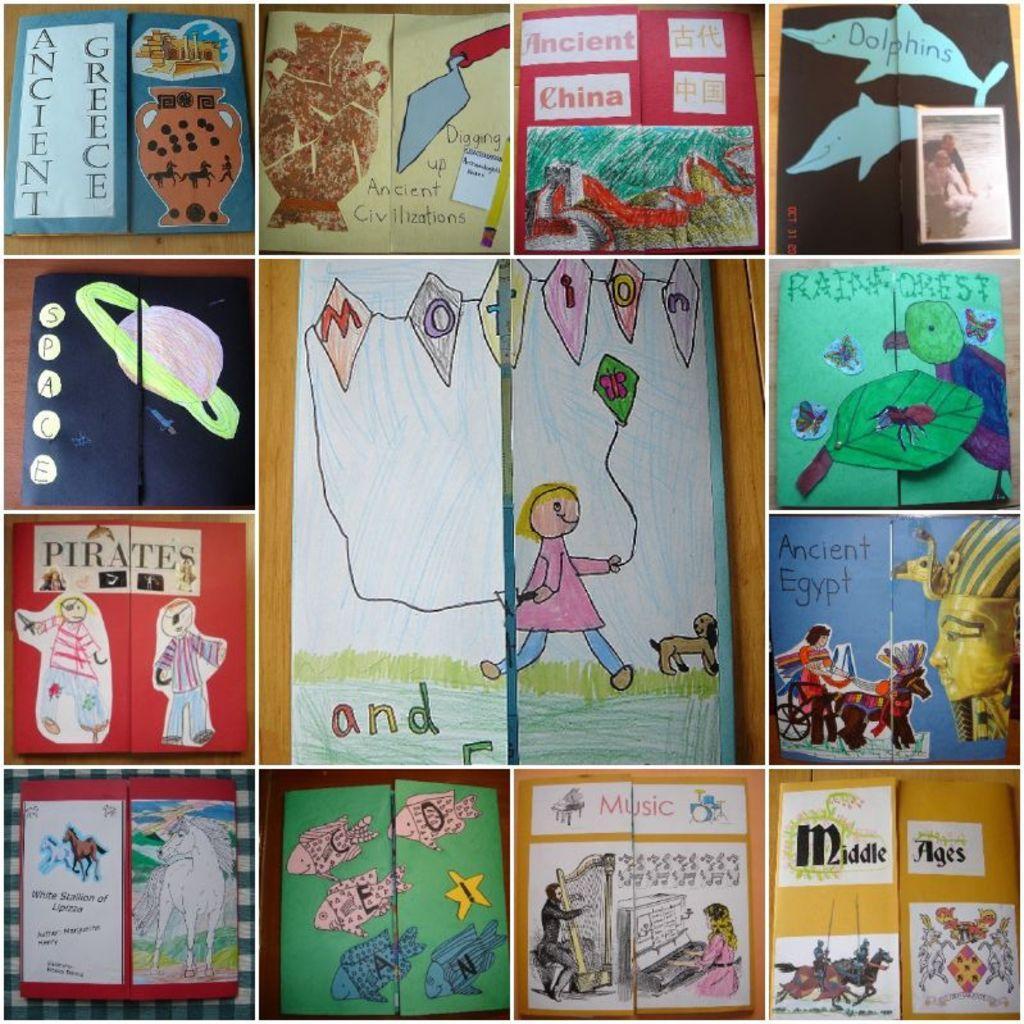How would you summarize this image in a sentence or two? In this picture there is a collage of few paintings. 